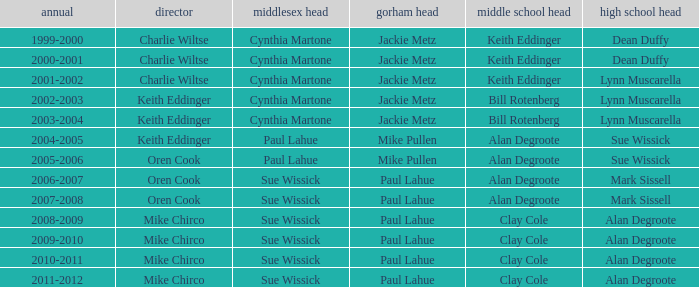How many years was lynn muscarella the high school principal and charlie wiltse the superintendent? 1.0. 